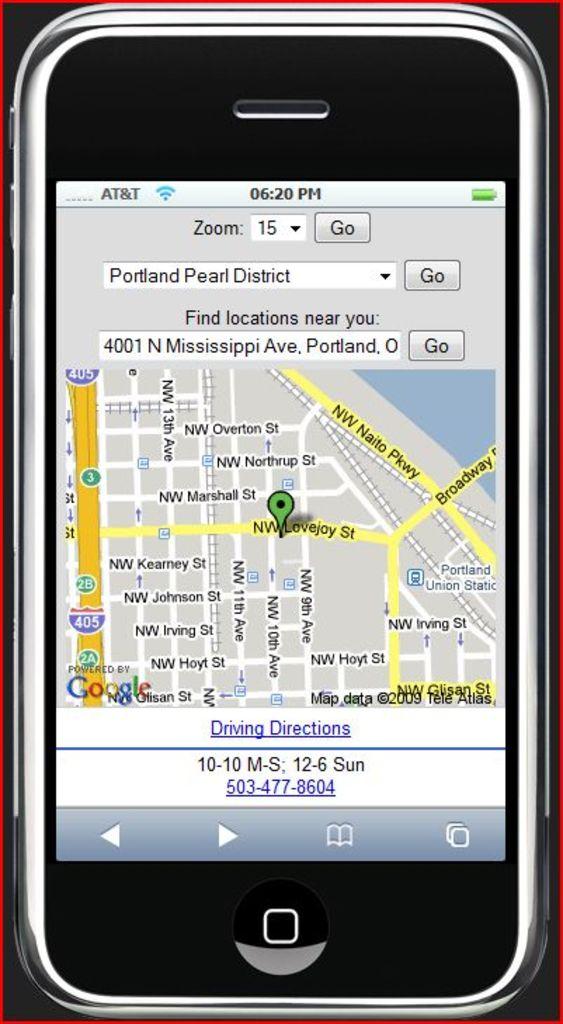Isthat google map?
Offer a very short reply. Yes. What cell service is being used?
Make the answer very short. At&t. 